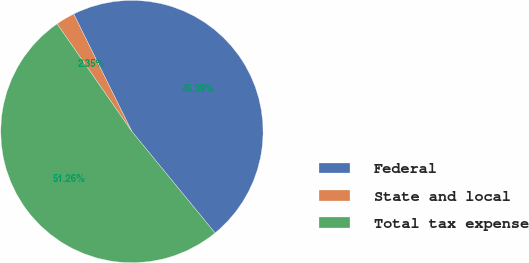<chart> <loc_0><loc_0><loc_500><loc_500><pie_chart><fcel>Federal<fcel>State and local<fcel>Total tax expense<nl><fcel>46.39%<fcel>2.35%<fcel>51.26%<nl></chart> 